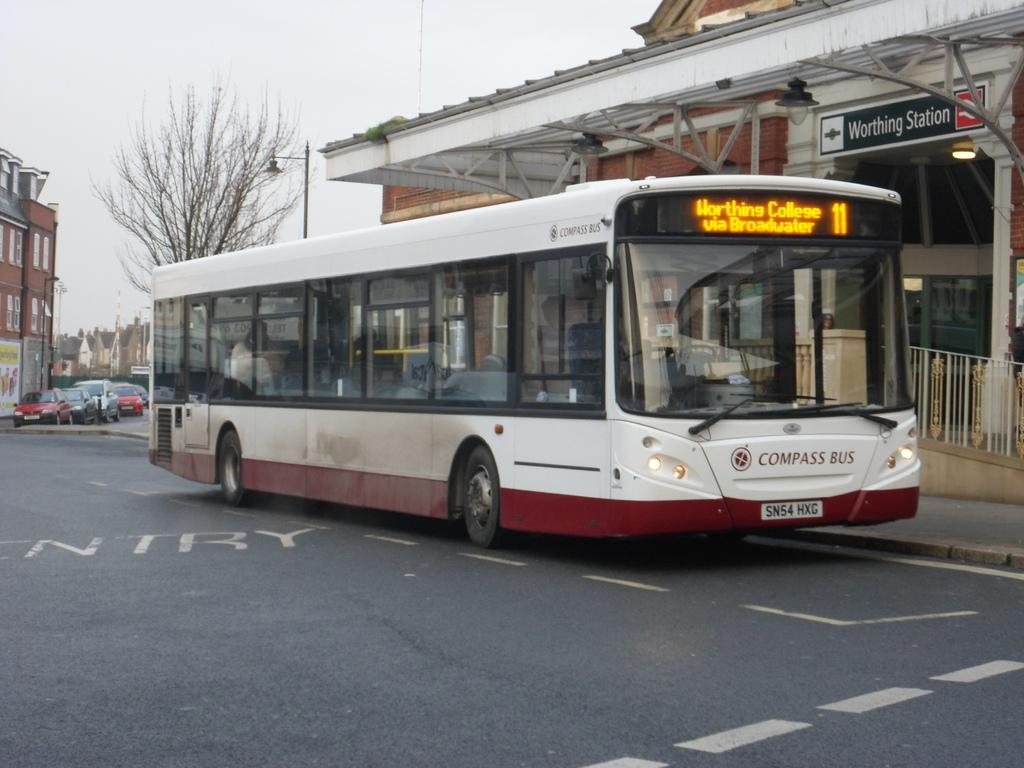<image>
Offer a succinct explanation of the picture presented. A bus with Worthing College via Broadwater on the front display. 